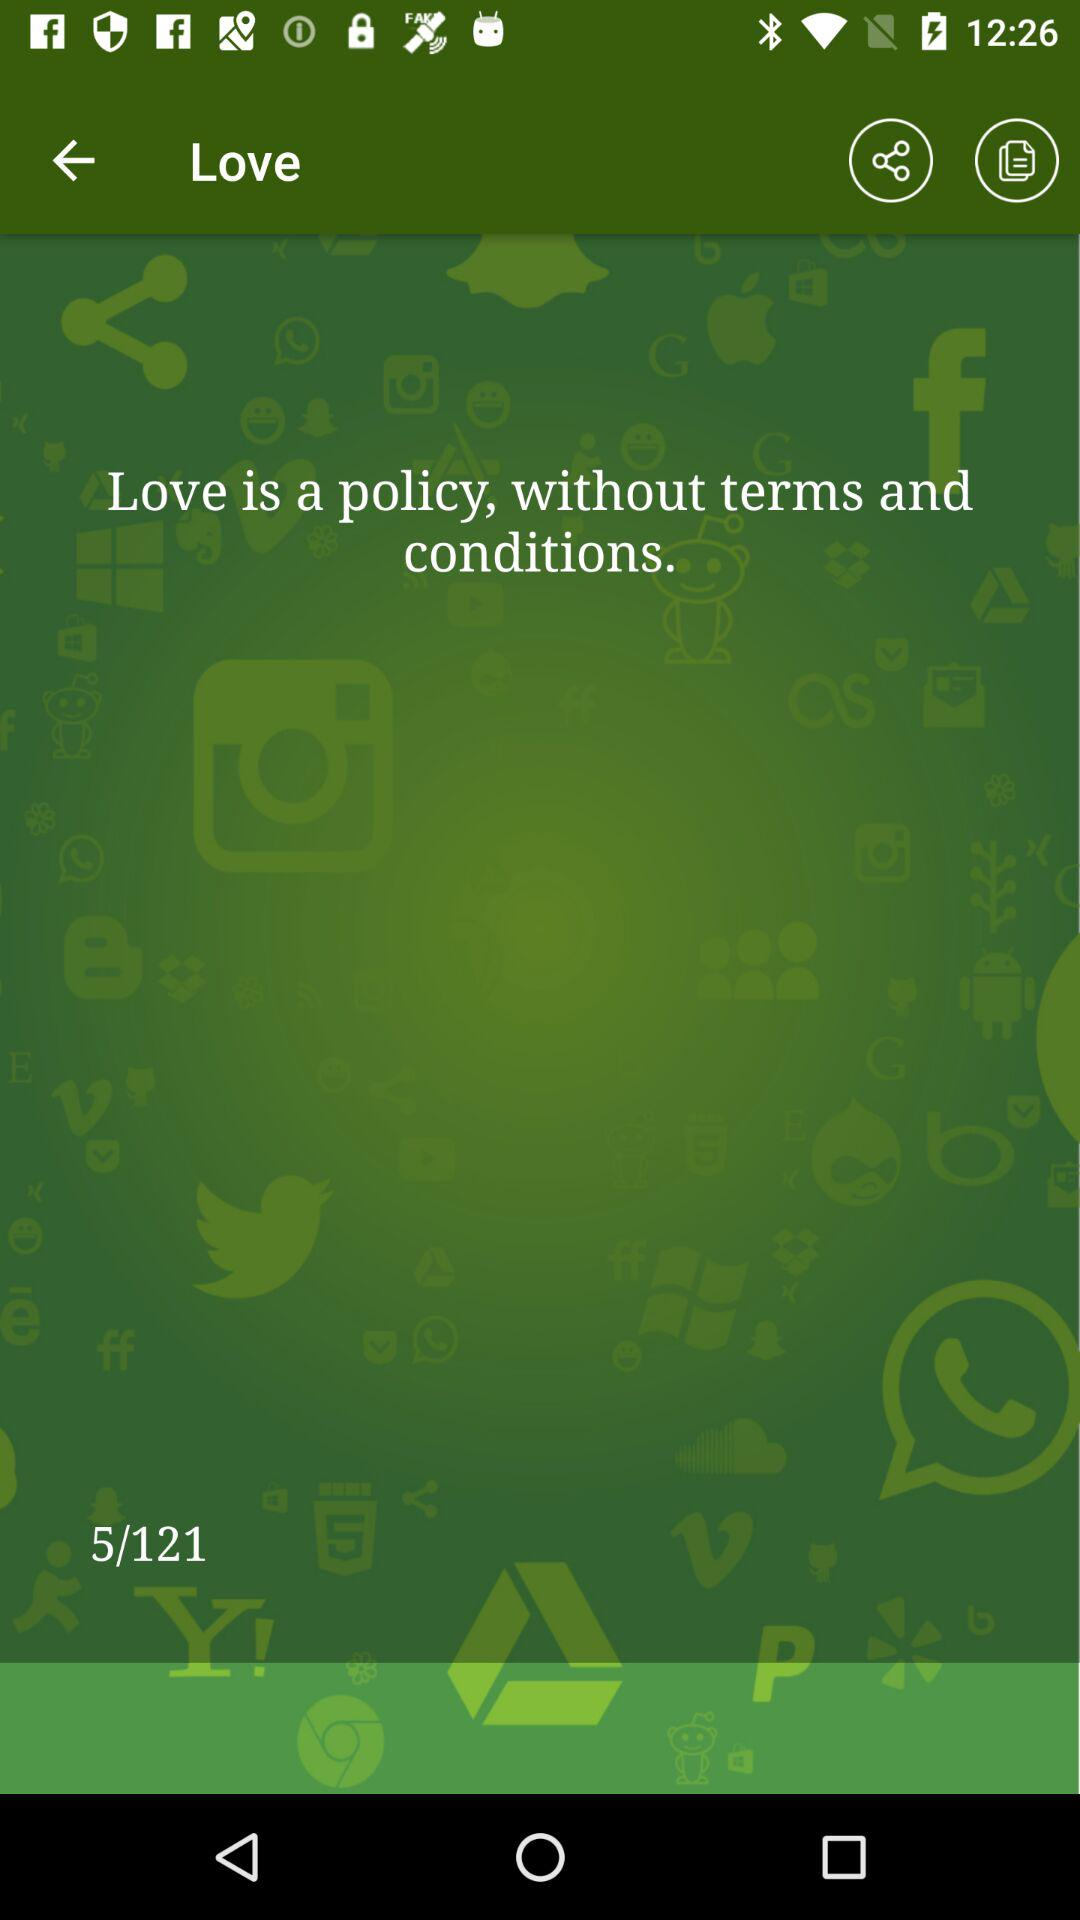Which page number are we currently on? You are currently on page number 5. 